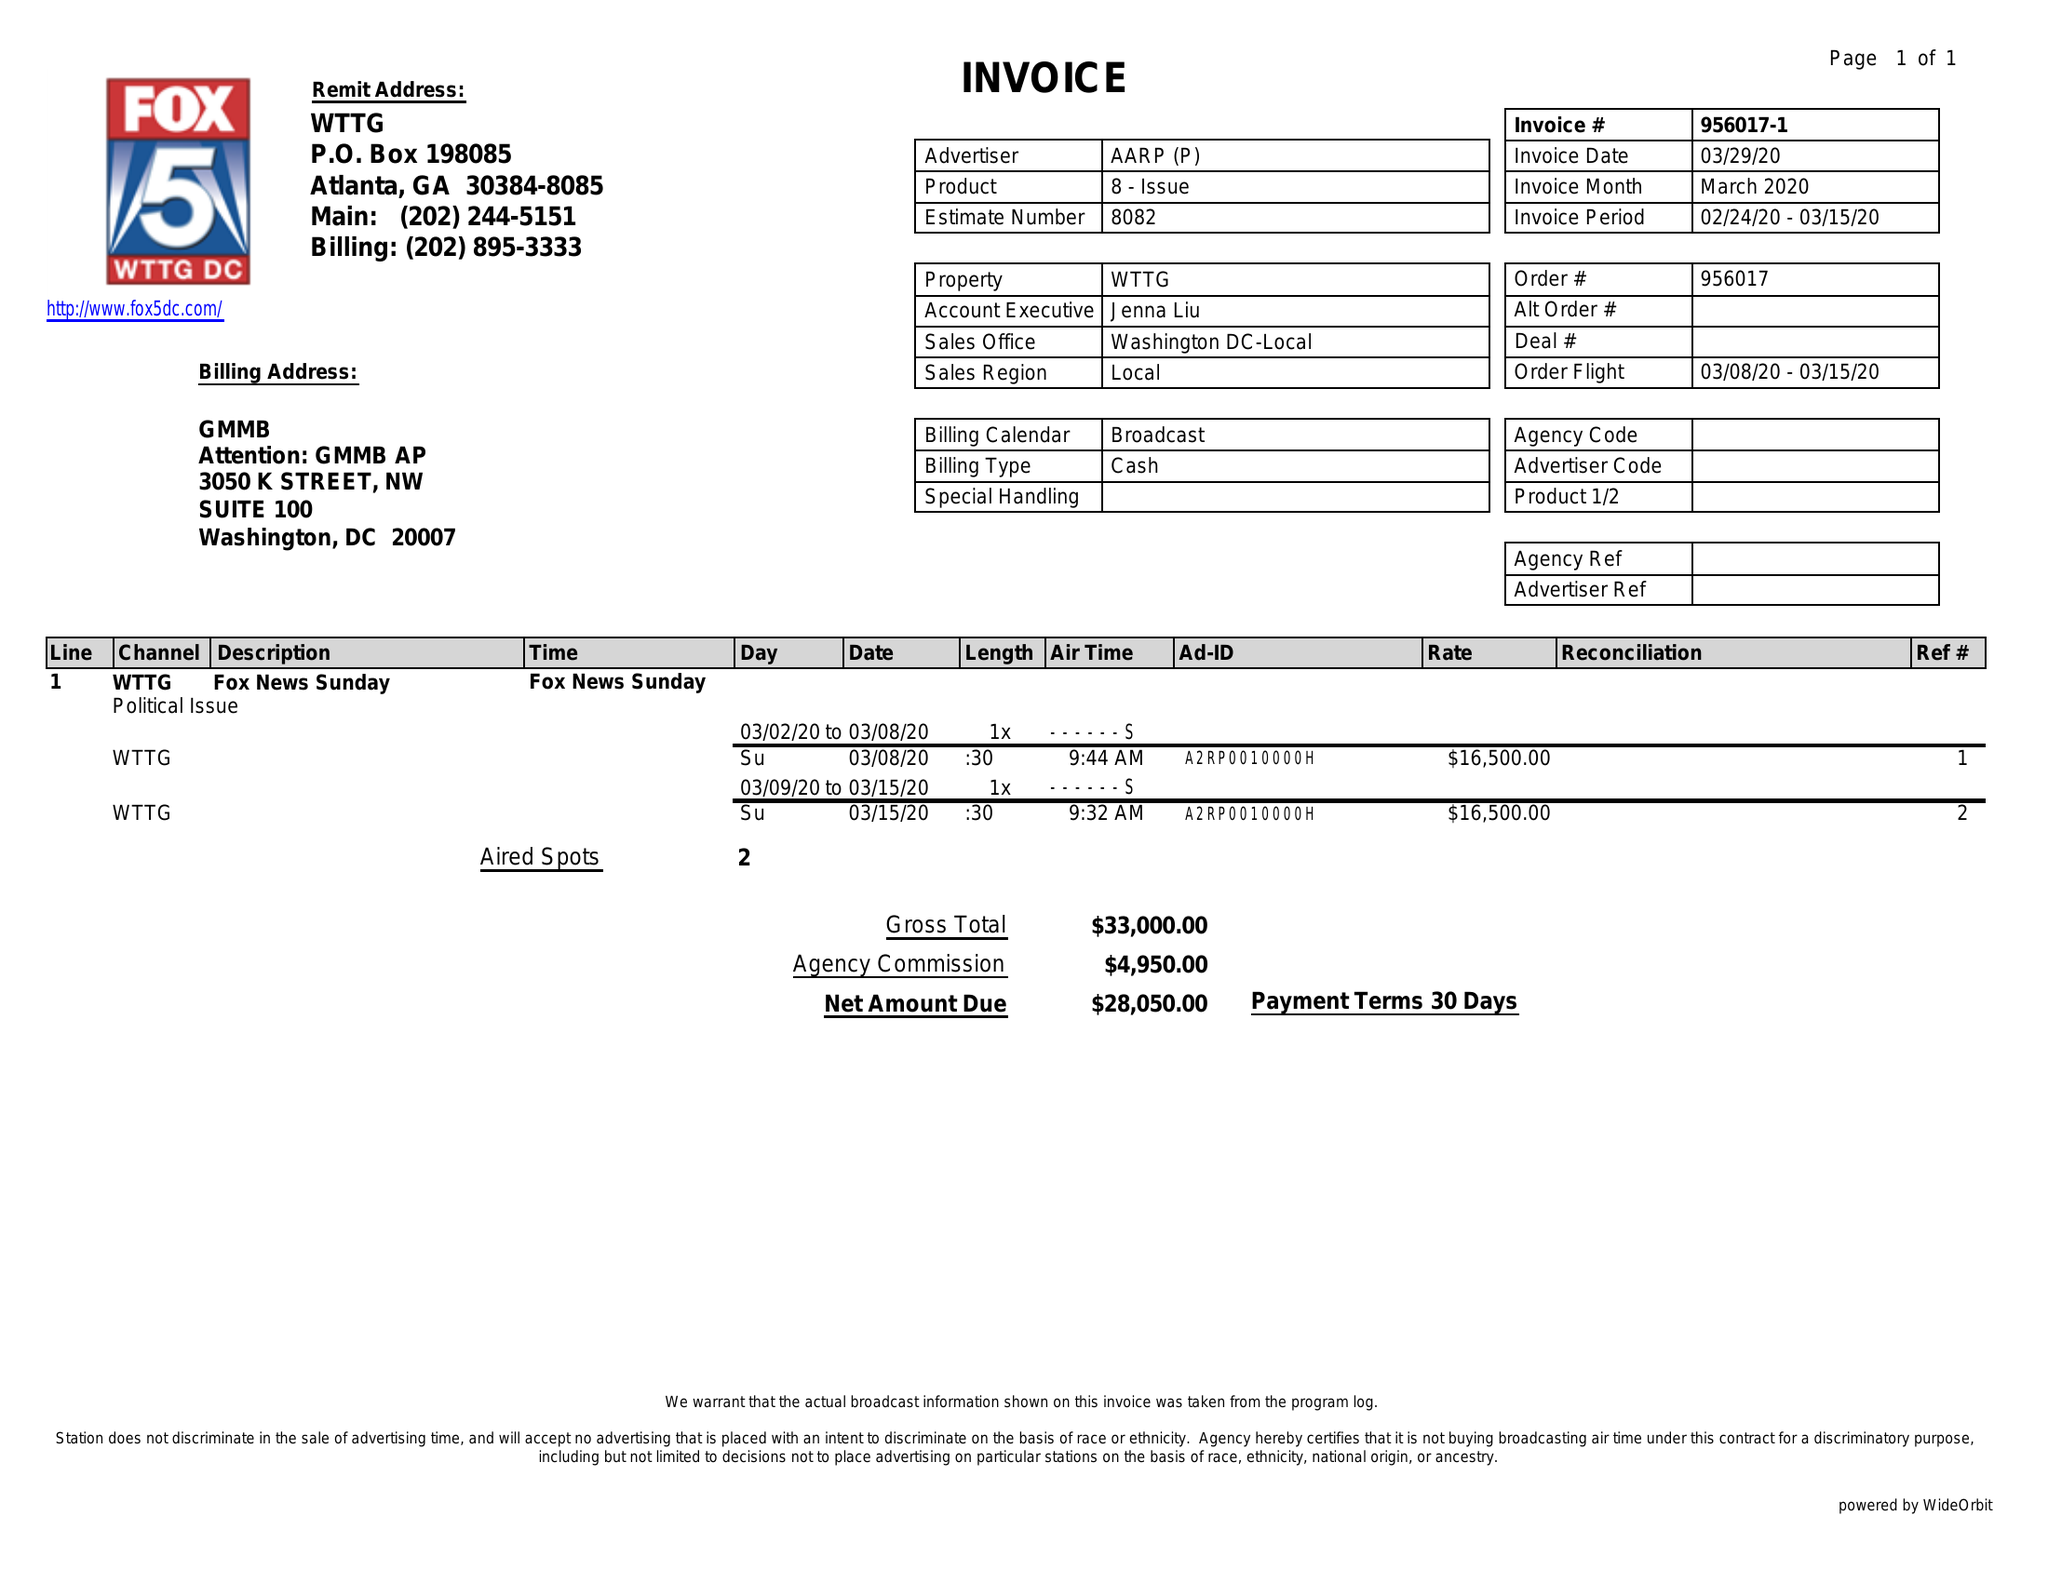What is the value for the gross_amount?
Answer the question using a single word or phrase. 33000.00 